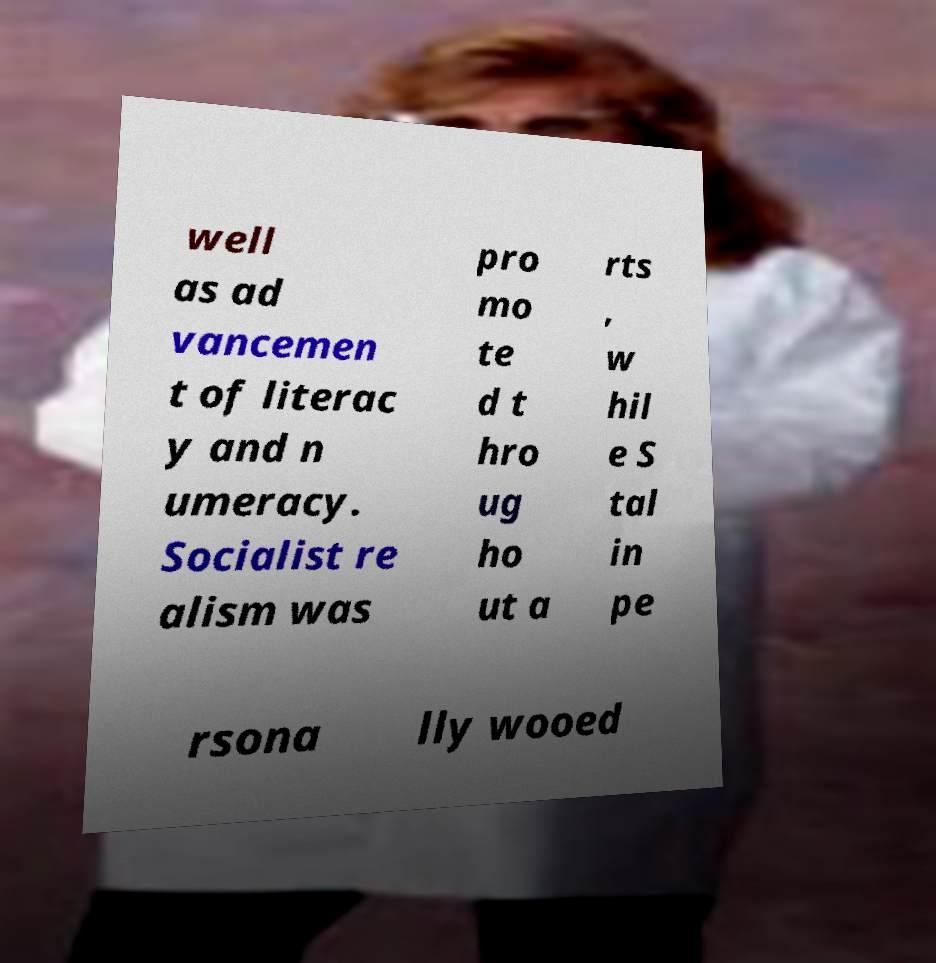There's text embedded in this image that I need extracted. Can you transcribe it verbatim? well as ad vancemen t of literac y and n umeracy. Socialist re alism was pro mo te d t hro ug ho ut a rts , w hil e S tal in pe rsona lly wooed 